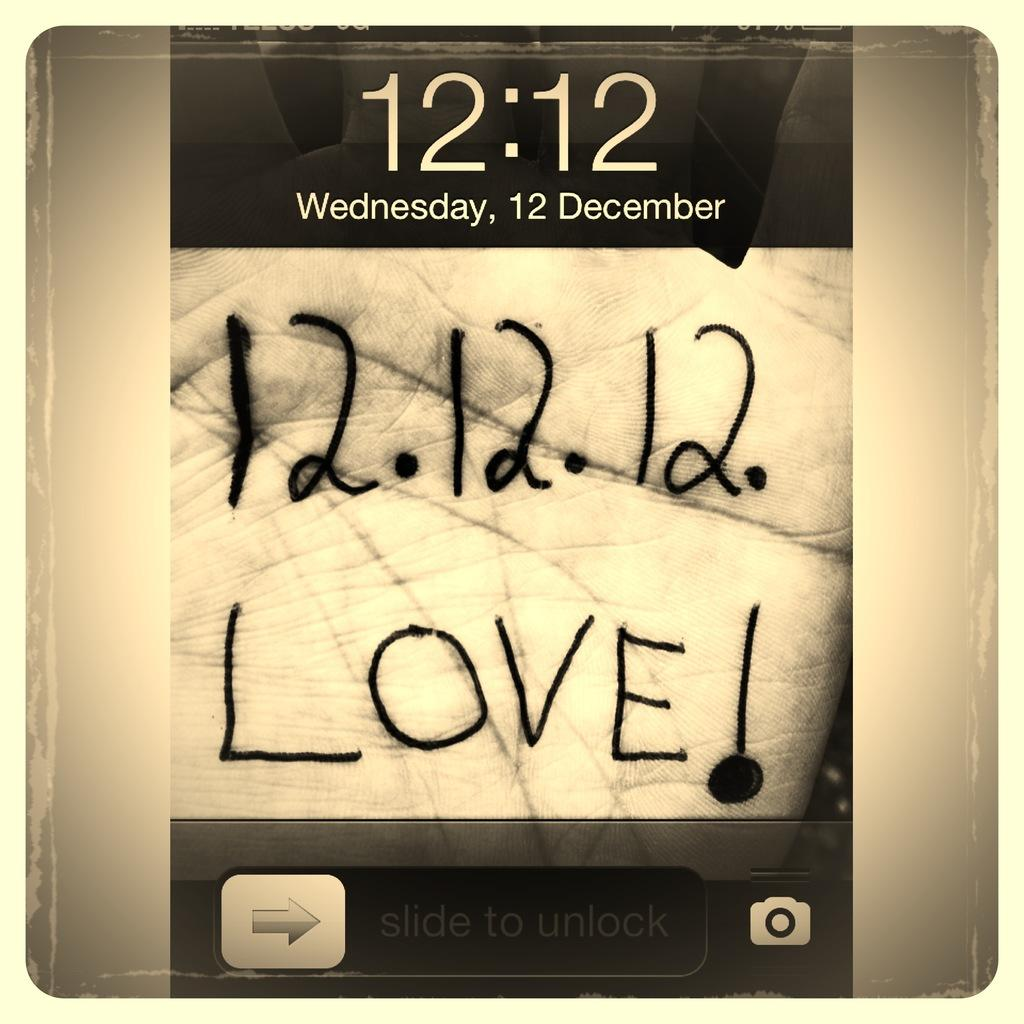<image>
Summarize the visual content of the image. A lock screen with someone's hand having the writing 12. 12. 12. Love! 